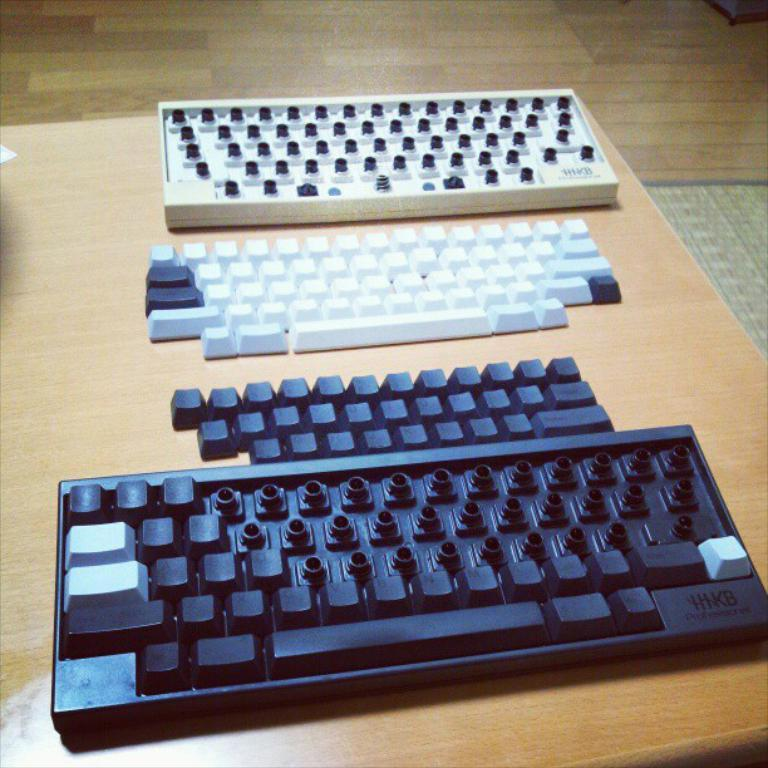<image>
Create a compact narrative representing the image presented. two keyboards from HIKB are taken partly apart with the keys off 